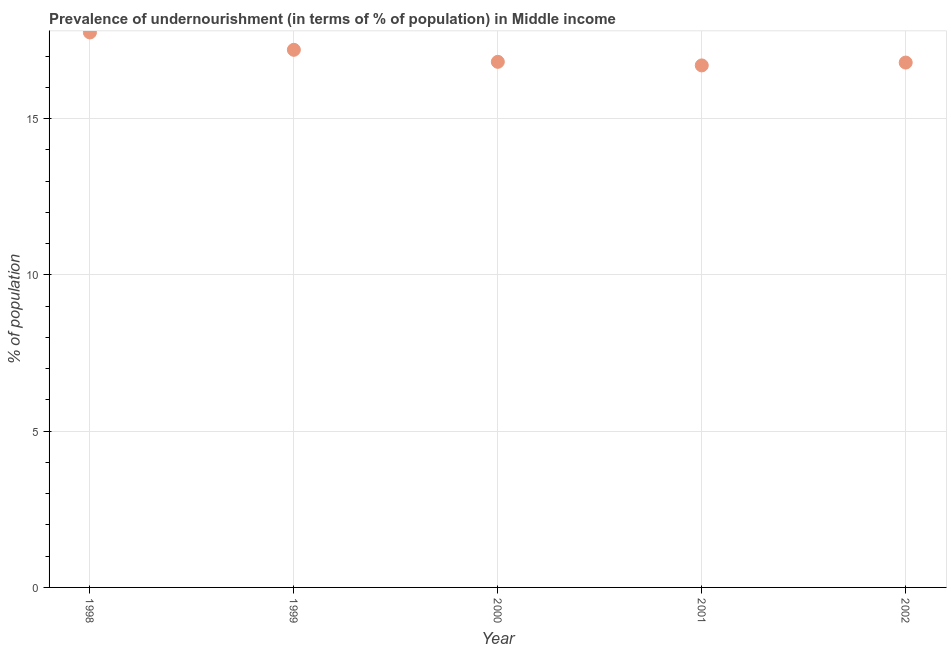What is the percentage of undernourished population in 2002?
Your response must be concise. 16.8. Across all years, what is the maximum percentage of undernourished population?
Your response must be concise. 17.76. Across all years, what is the minimum percentage of undernourished population?
Provide a succinct answer. 16.7. In which year was the percentage of undernourished population minimum?
Your answer should be very brief. 2001. What is the sum of the percentage of undernourished population?
Ensure brevity in your answer.  85.28. What is the difference between the percentage of undernourished population in 1999 and 2002?
Offer a terse response. 0.41. What is the average percentage of undernourished population per year?
Give a very brief answer. 17.06. What is the median percentage of undernourished population?
Your answer should be compact. 16.82. In how many years, is the percentage of undernourished population greater than 12 %?
Your answer should be compact. 5. Do a majority of the years between 1998 and 2001 (inclusive) have percentage of undernourished population greater than 7 %?
Provide a succinct answer. Yes. What is the ratio of the percentage of undernourished population in 1999 to that in 2001?
Keep it short and to the point. 1.03. Is the difference between the percentage of undernourished population in 1998 and 2002 greater than the difference between any two years?
Keep it short and to the point. No. What is the difference between the highest and the second highest percentage of undernourished population?
Your response must be concise. 0.55. What is the difference between the highest and the lowest percentage of undernourished population?
Provide a short and direct response. 1.05. Does the percentage of undernourished population monotonically increase over the years?
Keep it short and to the point. No. What is the difference between two consecutive major ticks on the Y-axis?
Give a very brief answer. 5. Are the values on the major ticks of Y-axis written in scientific E-notation?
Give a very brief answer. No. Does the graph contain any zero values?
Give a very brief answer. No. What is the title of the graph?
Make the answer very short. Prevalence of undernourishment (in terms of % of population) in Middle income. What is the label or title of the X-axis?
Make the answer very short. Year. What is the label or title of the Y-axis?
Provide a short and direct response. % of population. What is the % of population in 1998?
Offer a very short reply. 17.76. What is the % of population in 1999?
Keep it short and to the point. 17.2. What is the % of population in 2000?
Your answer should be compact. 16.82. What is the % of population in 2001?
Provide a succinct answer. 16.7. What is the % of population in 2002?
Ensure brevity in your answer.  16.8. What is the difference between the % of population in 1998 and 1999?
Provide a succinct answer. 0.55. What is the difference between the % of population in 1998 and 2000?
Make the answer very short. 0.94. What is the difference between the % of population in 1998 and 2001?
Your answer should be compact. 1.05. What is the difference between the % of population in 1998 and 2002?
Make the answer very short. 0.96. What is the difference between the % of population in 1999 and 2000?
Ensure brevity in your answer.  0.39. What is the difference between the % of population in 1999 and 2001?
Your answer should be compact. 0.5. What is the difference between the % of population in 1999 and 2002?
Offer a terse response. 0.41. What is the difference between the % of population in 2000 and 2001?
Offer a very short reply. 0.11. What is the difference between the % of population in 2000 and 2002?
Your response must be concise. 0.02. What is the difference between the % of population in 2001 and 2002?
Give a very brief answer. -0.09. What is the ratio of the % of population in 1998 to that in 1999?
Offer a terse response. 1.03. What is the ratio of the % of population in 1998 to that in 2000?
Your response must be concise. 1.06. What is the ratio of the % of population in 1998 to that in 2001?
Give a very brief answer. 1.06. What is the ratio of the % of population in 1998 to that in 2002?
Ensure brevity in your answer.  1.06. What is the ratio of the % of population in 1999 to that in 2000?
Provide a short and direct response. 1.02. What is the ratio of the % of population in 1999 to that in 2002?
Give a very brief answer. 1.02. What is the ratio of the % of population in 2000 to that in 2002?
Your response must be concise. 1. 